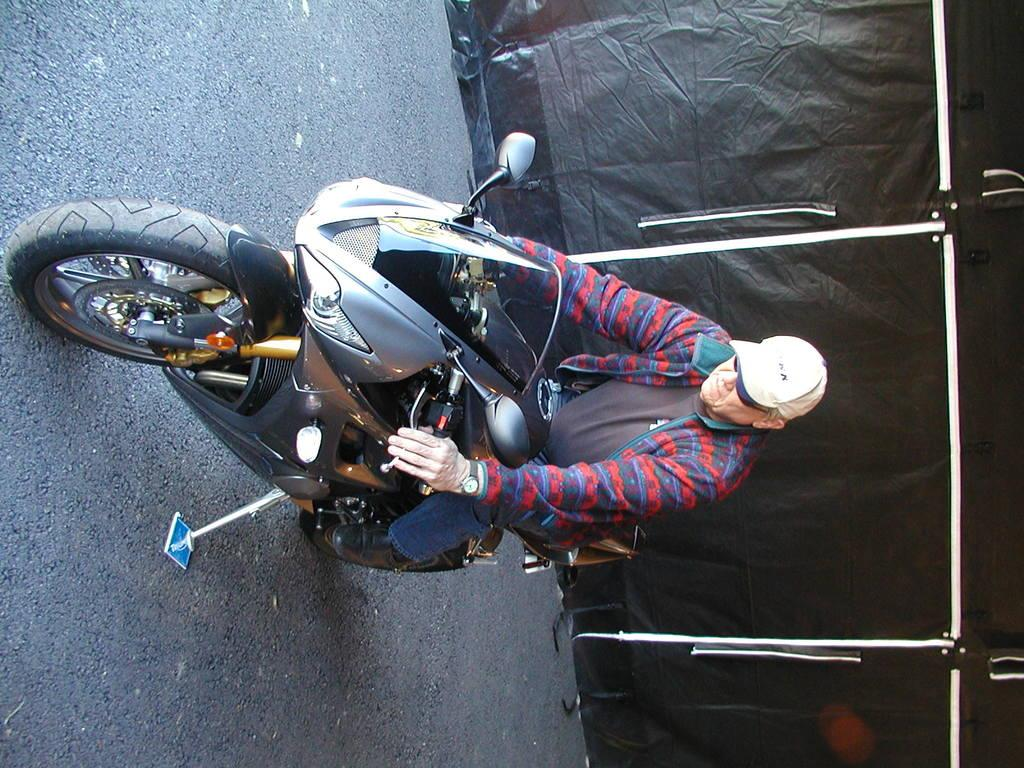What is the man in the image doing? The man is sitting on a bike in the image. Where is the bike located? The bike is on the road in the image. What color is the sheet visible in the image? There is a black color sheet in the image. What can be seen on the right side of the image? There are white poles on the right side of the image. What type of screw is being used to hold the yarn together in the image? There is no screw or yarn present in the image; it features a man sitting on a bike on the road, a black color sheet, and white poles on the right side. 